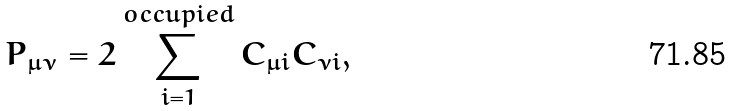Convert formula to latex. <formula><loc_0><loc_0><loc_500><loc_500>P _ { \mu \nu } = 2 \sum _ { i = 1 } ^ { o c c u p i e d } C _ { \mu i } C _ { \nu i } ,</formula> 